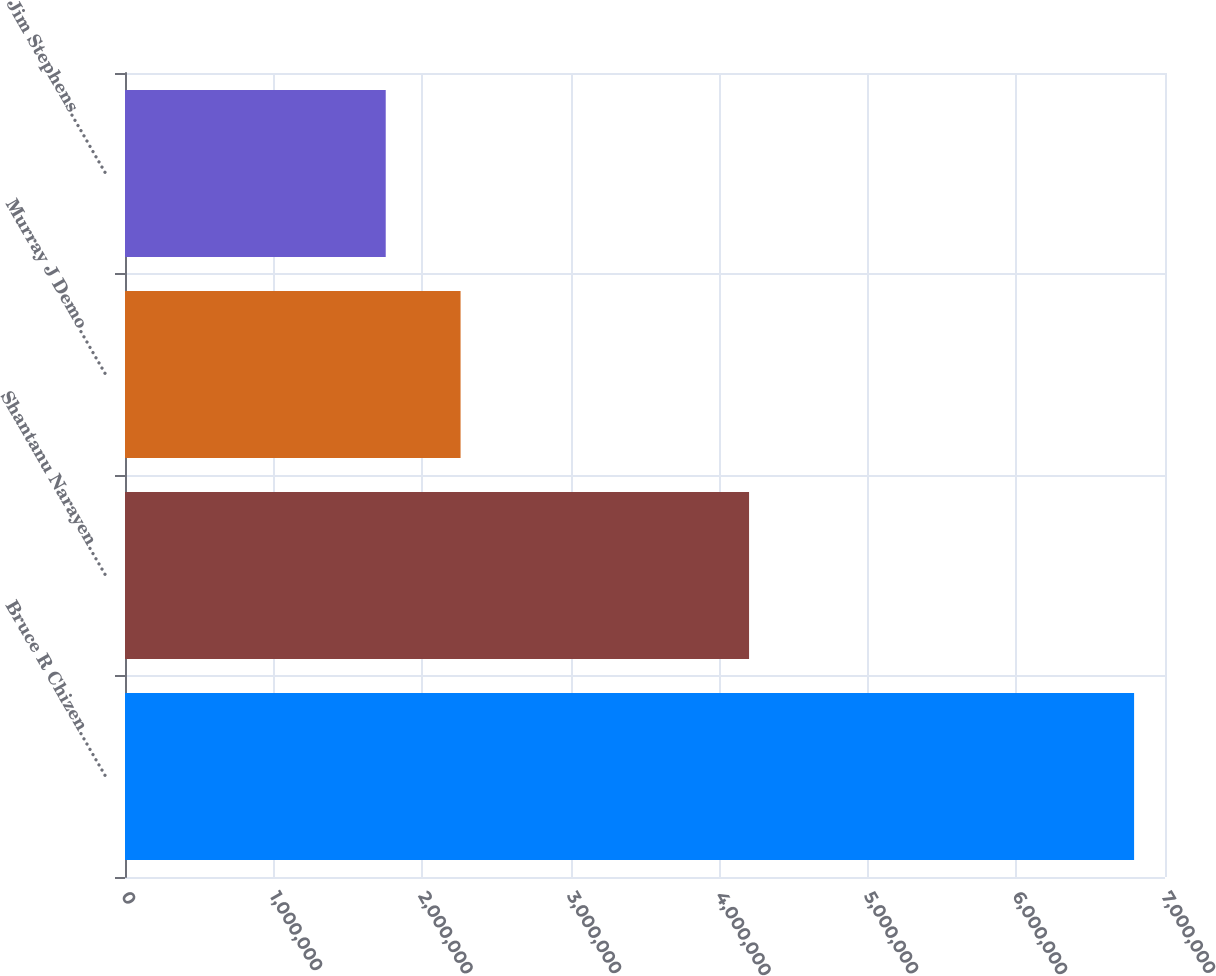<chart> <loc_0><loc_0><loc_500><loc_500><bar_chart><fcel>Bruce R Chizen………<fcel>Shantanu Narayen……<fcel>Murray J Demo………<fcel>Jim Stephens…………<nl><fcel>6.792e+06<fcel>4.20038e+06<fcel>2.25861e+06<fcel>1.7549e+06<nl></chart> 